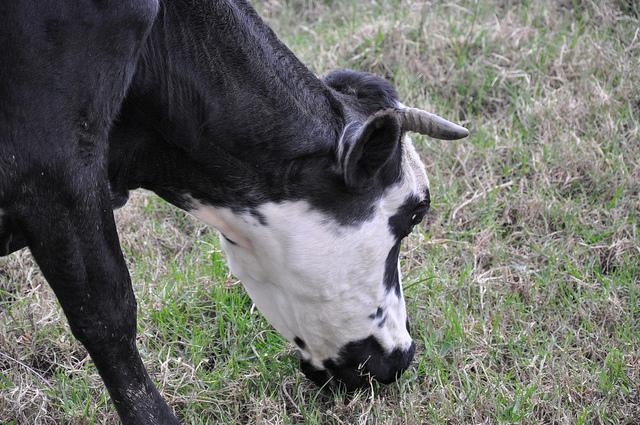What are the cows eating?
Be succinct. Grass. Is this a wild animal?
Be succinct. No. What color are the cows eyes reflecting?
Keep it brief. White. Is this cow hungry?
Write a very short answer. Yes. In what position is the cow?
Write a very short answer. Standing. What is on the cow's ear?
Write a very short answer. Hair. Is this a black Angus?
Concise answer only. No. How many cows are in this picture?
Quick response, please. 1. Is this a full grown cow?
Answer briefly. Yes. Is this a real animal?
Concise answer only. Yes. Does the cow have whiskers?
Keep it brief. No. 